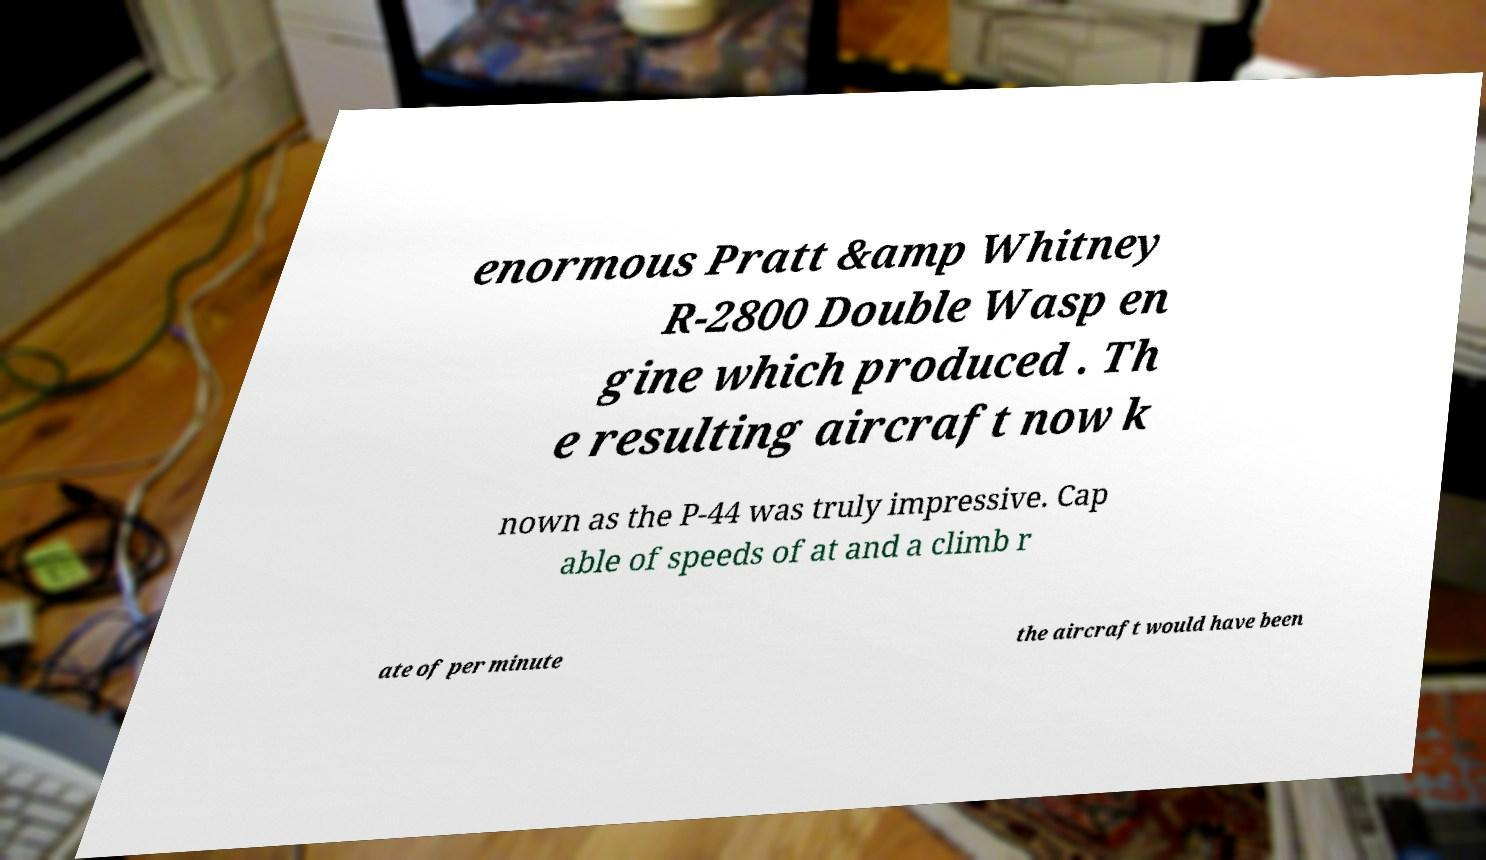Please identify and transcribe the text found in this image. enormous Pratt &amp Whitney R-2800 Double Wasp en gine which produced . Th e resulting aircraft now k nown as the P-44 was truly impressive. Cap able of speeds of at and a climb r ate of per minute the aircraft would have been 